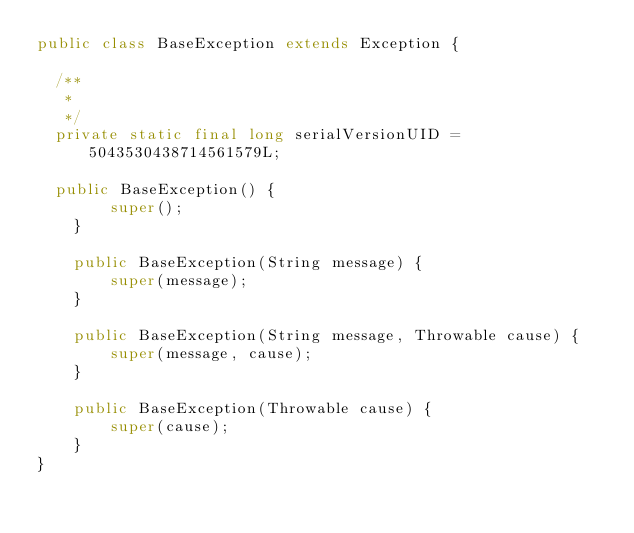Convert code to text. <code><loc_0><loc_0><loc_500><loc_500><_Java_>public class BaseException extends Exception {

	/**
	 * 
	 */
	private static final long serialVersionUID = 5043530438714561579L;

	public BaseException() {
        super();
    }

    public BaseException(String message) {
        super(message);
    }

    public BaseException(String message, Throwable cause) {
        super(message, cause);
    }

    public BaseException(Throwable cause) {
        super(cause);
    }
}
</code> 